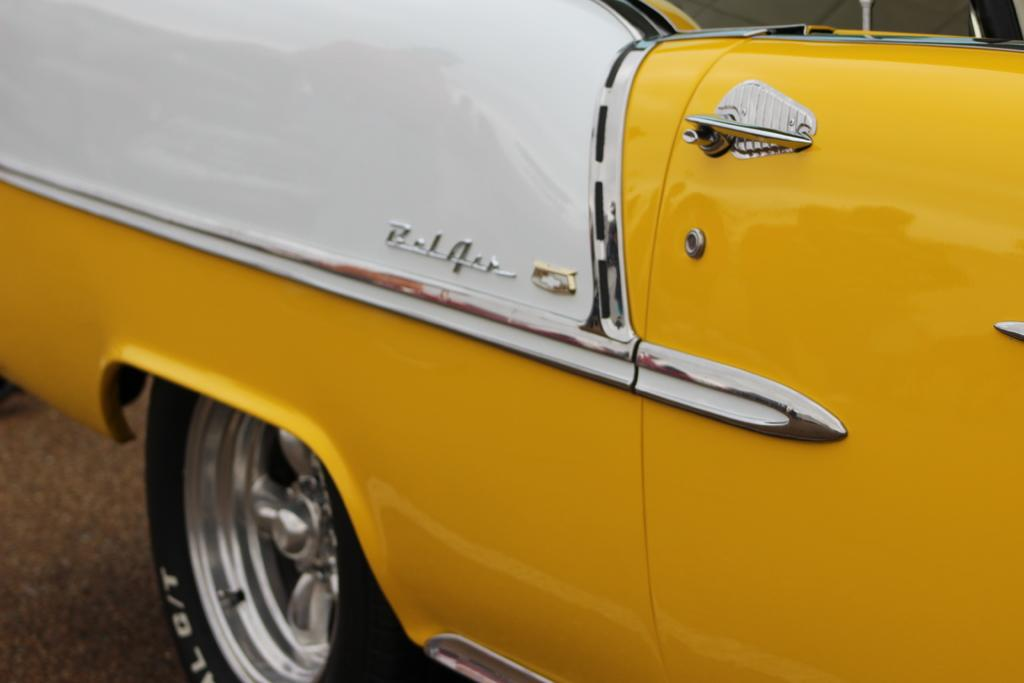What is the main subject of the image? There is a vehicle in the image. Where is the vehicle located? The vehicle is on the road. How many kitties are playing with the chickens in the image? There are no kitties or chickens present in the image; it features a vehicle on the road. What is the thumb doing in the image? There is no thumb present in the image. 